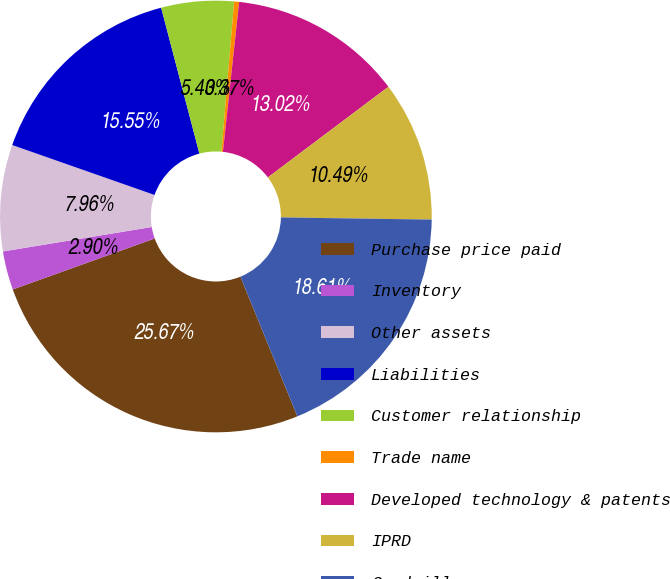<chart> <loc_0><loc_0><loc_500><loc_500><pie_chart><fcel>Purchase price paid<fcel>Inventory<fcel>Other assets<fcel>Liabilities<fcel>Customer relationship<fcel>Trade name<fcel>Developed technology & patents<fcel>IPRD<fcel>Goodwill<nl><fcel>25.67%<fcel>2.9%<fcel>7.96%<fcel>15.55%<fcel>5.43%<fcel>0.37%<fcel>13.02%<fcel>10.49%<fcel>18.61%<nl></chart> 